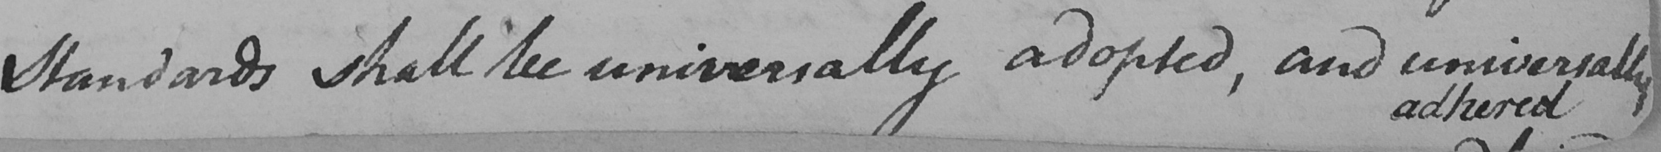Transcribe the text shown in this historical manuscript line. Standards shall be universally adopted , and universally 